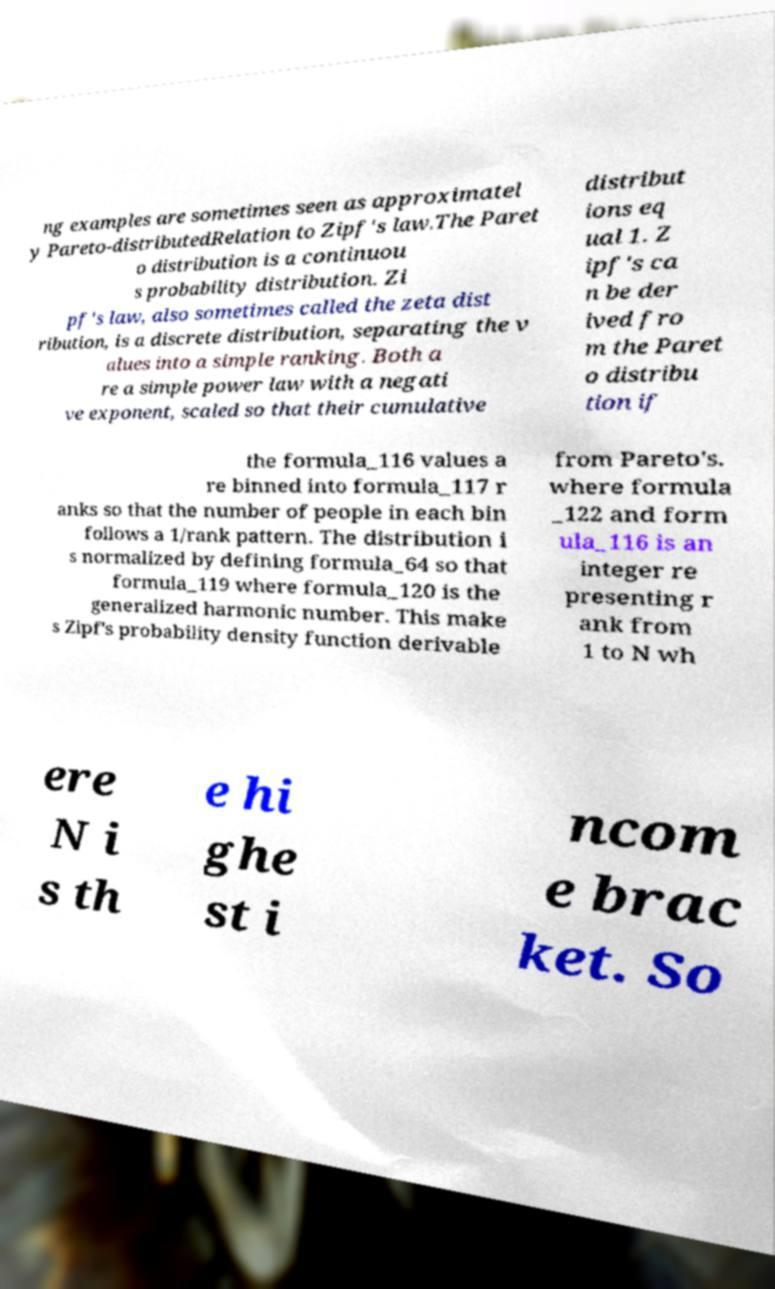Can you accurately transcribe the text from the provided image for me? ng examples are sometimes seen as approximatel y Pareto-distributedRelation to Zipf's law.The Paret o distribution is a continuou s probability distribution. Zi pf's law, also sometimes called the zeta dist ribution, is a discrete distribution, separating the v alues into a simple ranking. Both a re a simple power law with a negati ve exponent, scaled so that their cumulative distribut ions eq ual 1. Z ipf's ca n be der ived fro m the Paret o distribu tion if the formula_116 values a re binned into formula_117 r anks so that the number of people in each bin follows a 1/rank pattern. The distribution i s normalized by defining formula_64 so that formula_119 where formula_120 is the generalized harmonic number. This make s Zipf's probability density function derivable from Pareto's. where formula _122 and form ula_116 is an integer re presenting r ank from 1 to N wh ere N i s th e hi ghe st i ncom e brac ket. So 